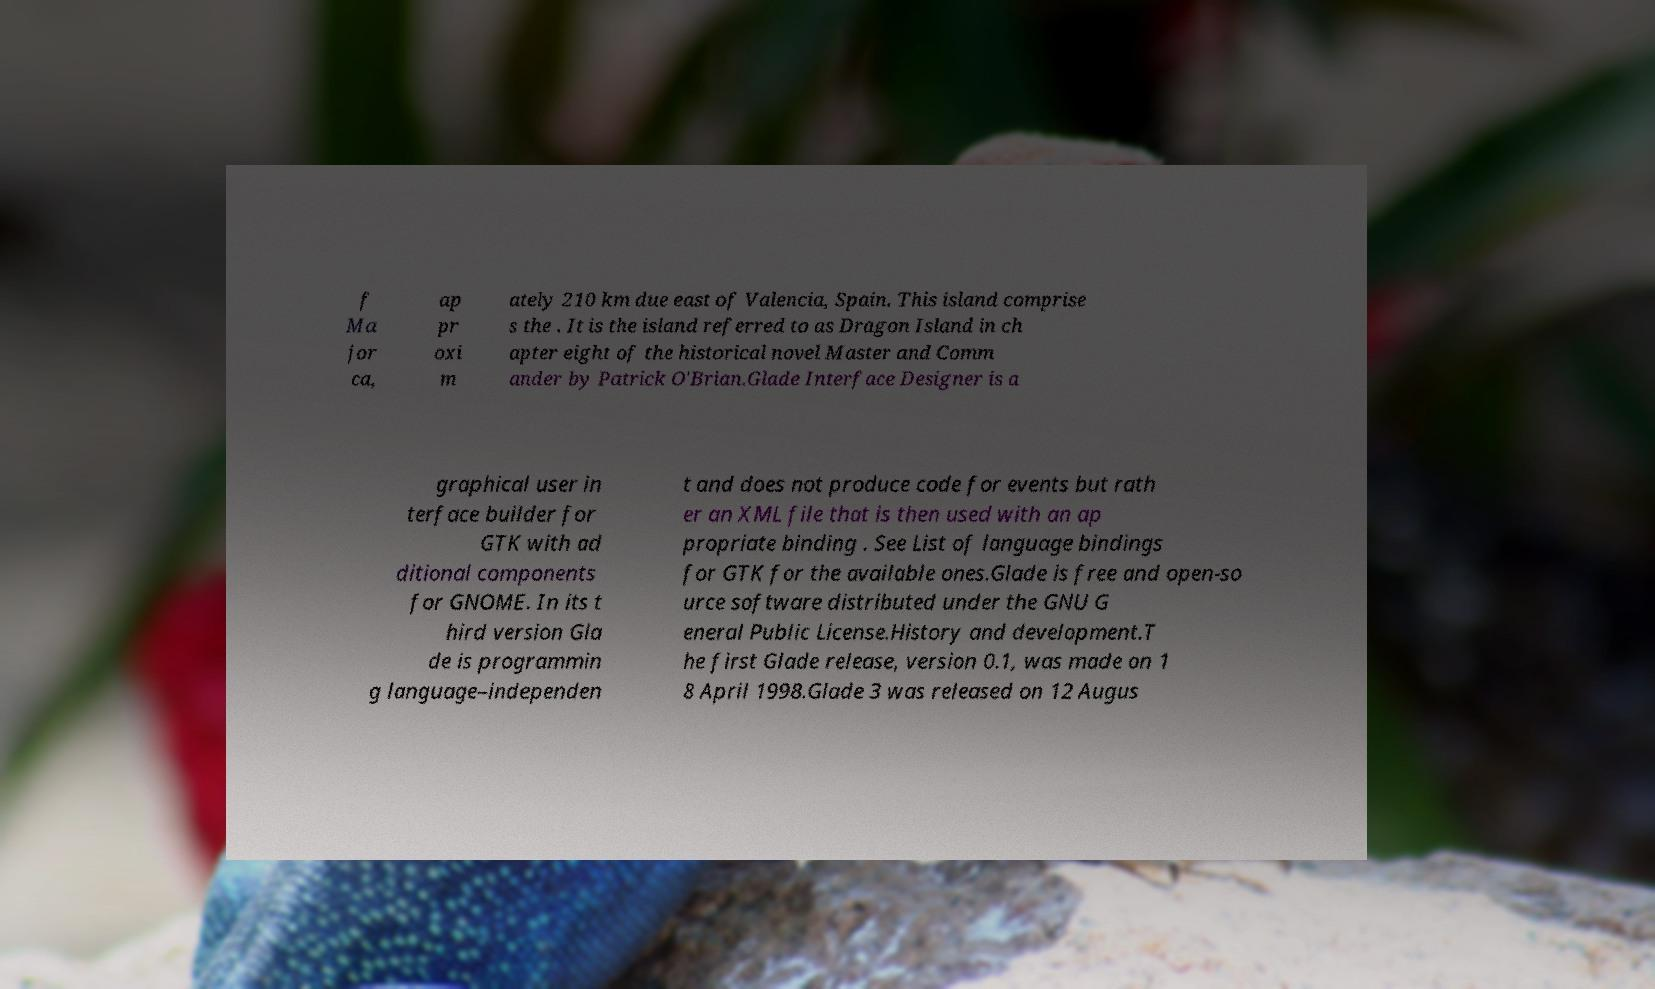What messages or text are displayed in this image? I need them in a readable, typed format. f Ma jor ca, ap pr oxi m ately 210 km due east of Valencia, Spain. This island comprise s the . It is the island referred to as Dragon Island in ch apter eight of the historical novel Master and Comm ander by Patrick O'Brian.Glade Interface Designer is a graphical user in terface builder for GTK with ad ditional components for GNOME. In its t hird version Gla de is programmin g language–independen t and does not produce code for events but rath er an XML file that is then used with an ap propriate binding . See List of language bindings for GTK for the available ones.Glade is free and open-so urce software distributed under the GNU G eneral Public License.History and development.T he first Glade release, version 0.1, was made on 1 8 April 1998.Glade 3 was released on 12 Augus 